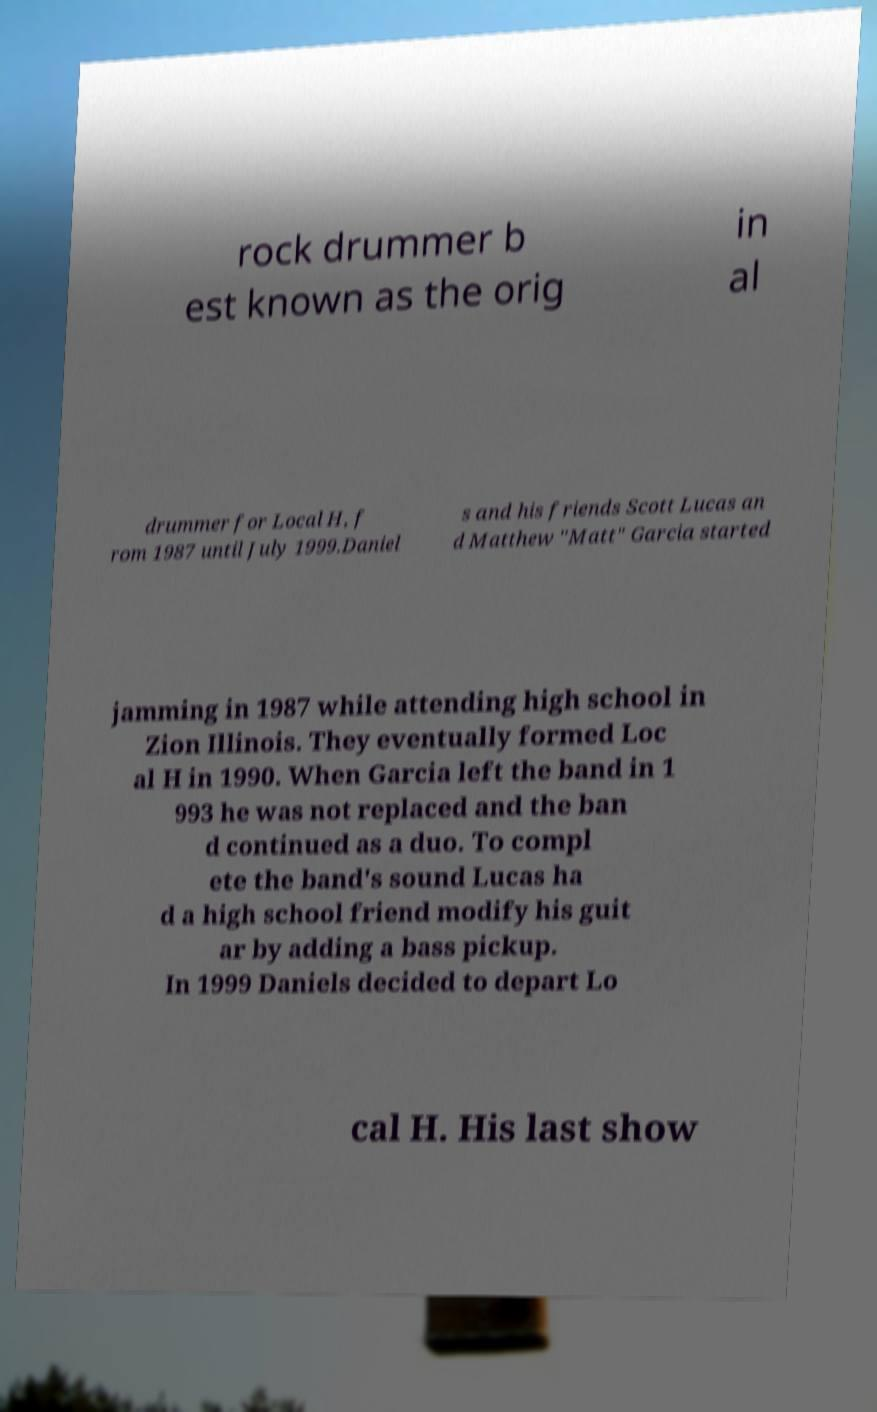I need the written content from this picture converted into text. Can you do that? rock drummer b est known as the orig in al drummer for Local H, f rom 1987 until July 1999.Daniel s and his friends Scott Lucas an d Matthew "Matt" Garcia started jamming in 1987 while attending high school in Zion Illinois. They eventually formed Loc al H in 1990. When Garcia left the band in 1 993 he was not replaced and the ban d continued as a duo. To compl ete the band's sound Lucas ha d a high school friend modify his guit ar by adding a bass pickup. In 1999 Daniels decided to depart Lo cal H. His last show 